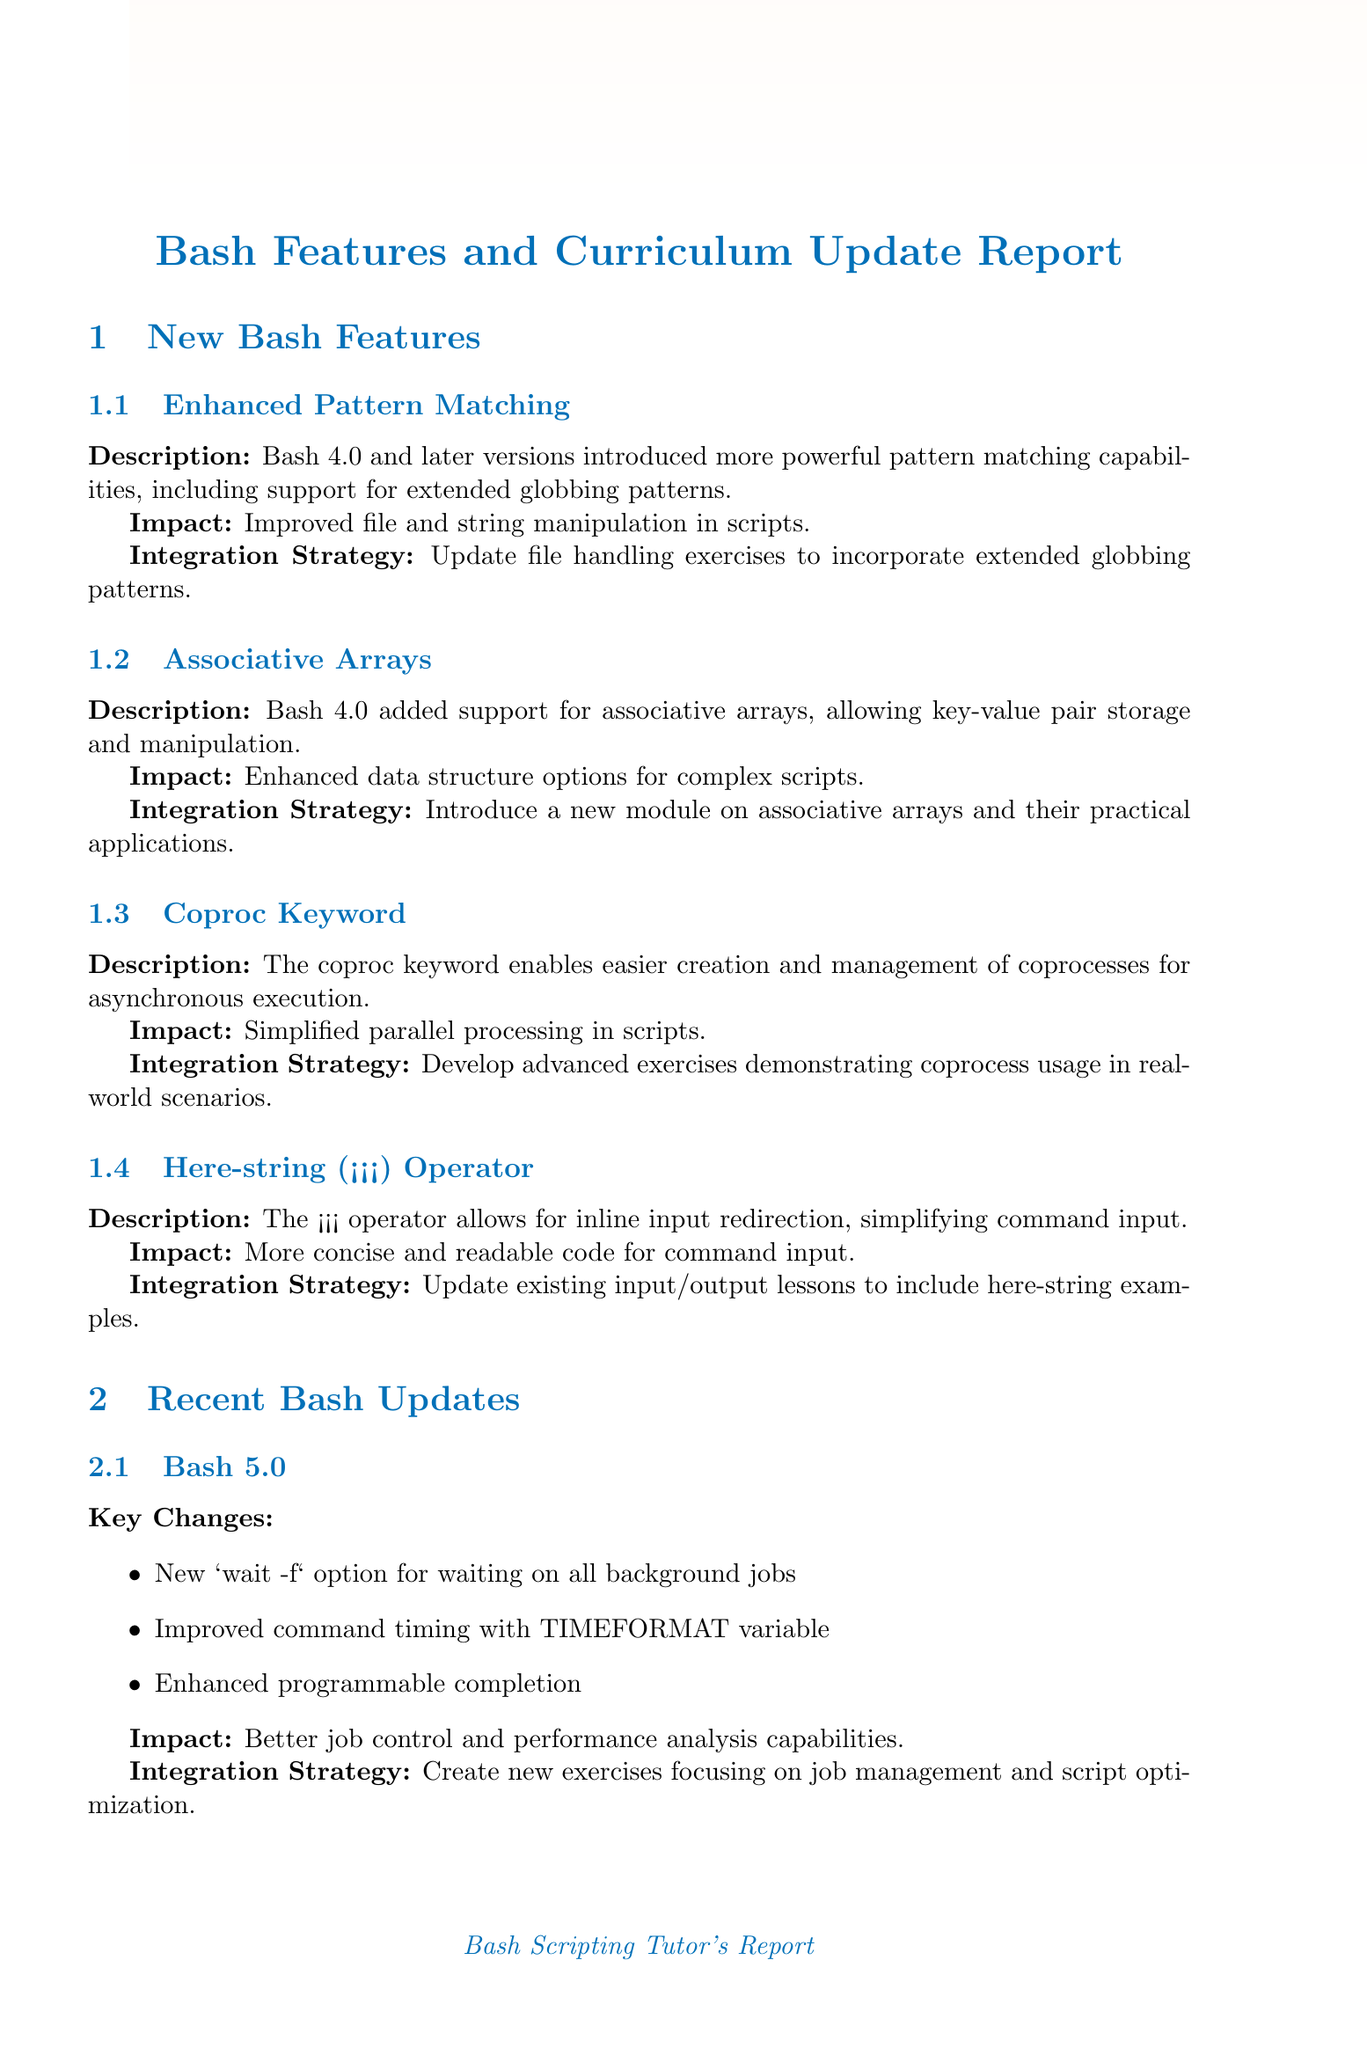What is the feature introduced in Bash 4.0 that allows key-value pair storage? The feature is known as associative arrays, which enable the storage and manipulation of key-value pairs.
Answer: associative arrays What impact does the coproc keyword have on Bash scripts? The coproc keyword simplifies parallel processing in scripts, allowing easier creation and management of coprocesses.
Answer: Simplified parallel processing What is a proposed integration strategy for enhancing file handling lessons? The integration strategy suggests updating file handling exercises to include extended globbing patterns and associative arrays.
Answer: Update exercises Which version of Bash introduced the new wait -f option? The new wait -f option was introduced in Bash 5.0.
Answer: Bash 5.0 What are the benefits of incorporating new quoting features in string-related exercises? Incorporating new quoting features enhances skills in text processing and data extraction for students.
Answer: Enhanced skills How many key changes were introduced in Bash 5.1? There are three key changes listed for Bash 5.1.
Answer: three What is the implementation for the strategy of gradually introducing new Bash features? The implementation involves updating one module per week, with supplementary materials provided for self-study.
Answer: Update one module per week What type of learning assignment is suggested for real-world project integration? The suggestion is to revise current projects to utilize recent Bash capabilities in existing project-based learning assignments.
Answer: Revise current projects 